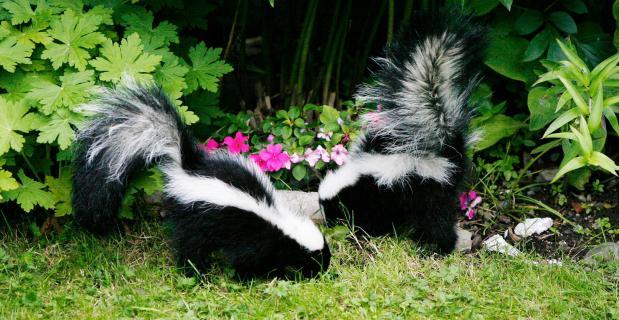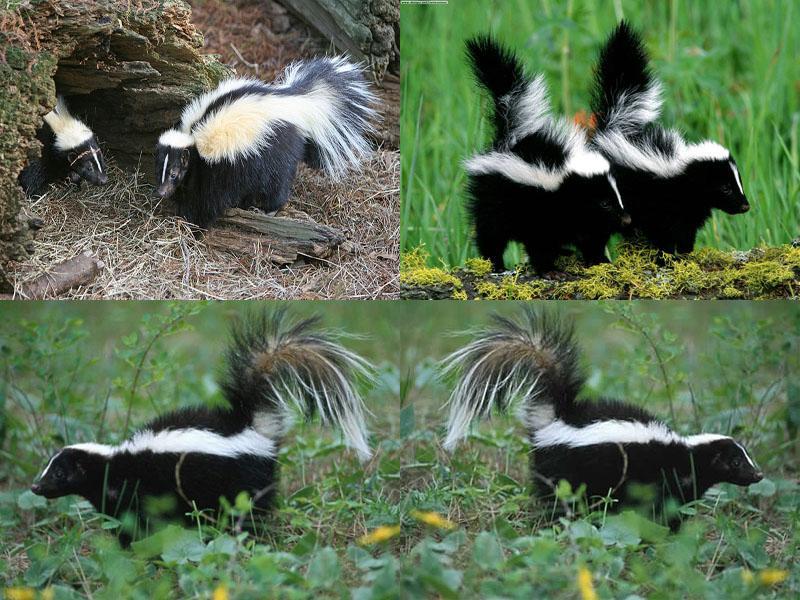The first image is the image on the left, the second image is the image on the right. For the images shown, is this caption "There are six skunks pictured." true? Answer yes or no. No. 